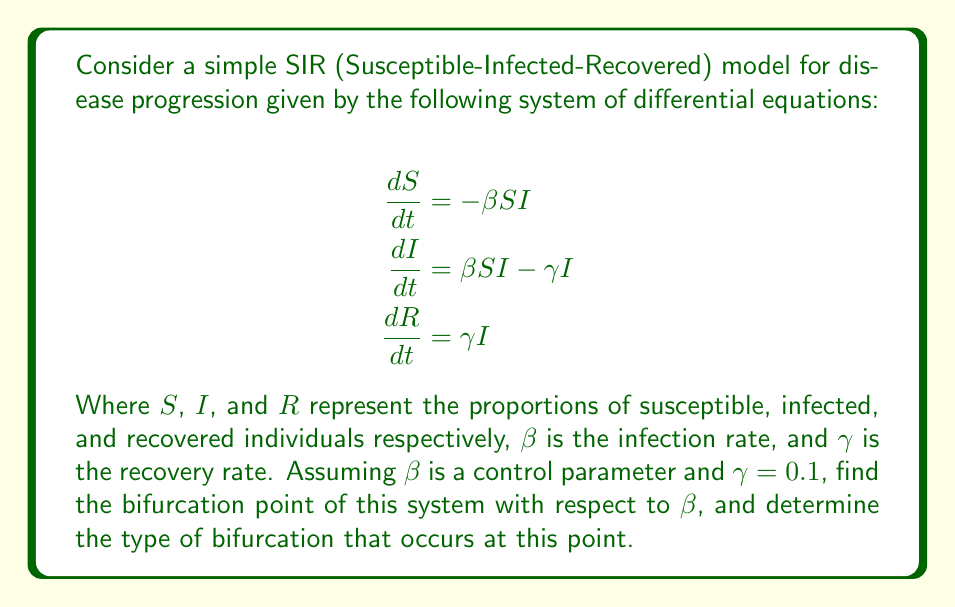Can you solve this math problem? To find the bifurcation point and determine the type of bifurcation, we'll follow these steps:

1) First, we need to find the equilibrium points of the system. At equilibrium, all derivatives are zero:

   $$\begin{align}
   -\beta SI &= 0 \\
   \beta SI - \gamma I &= 0 \\
   \gamma I &= 0
   \end{align}$$

2) From the third equation, we see that either $I = 0$ or $\gamma = 0$. Since $\gamma \neq 0$, we must have $I = 0$ at equilibrium.

3) This gives us two possible equilibrium points:
   - Disease-free equilibrium (DFE): $(S, I, R) = (1, 0, 0)$
   - Endemic equilibrium (EE): $(S, I, R) = (\frac{\gamma}{\beta}, \frac{\beta - \gamma}{\beta}, 1 - \frac{\gamma}{\beta})$

4) The endemic equilibrium only exists when $\beta > \gamma$, as $I$ must be non-negative.

5) To analyze stability, we need to compute the Jacobian matrix:

   $$J = \begin{bmatrix}
   -\beta I & -\beta S & 0 \\
   \beta I & \beta S - \gamma & 0 \\
   0 & \gamma & 0
   \end{bmatrix}$$

6) At the DFE, the Jacobian becomes:

   $$J_{DFE} = \begin{bmatrix}
   0 & -\beta & 0 \\
   0 & \beta - \gamma & 0 \\
   0 & \gamma & 0
   \end{bmatrix}$$

7) The eigenvalues of $J_{DFE}$ are $\lambda_1 = 0$, $\lambda_2 = \beta - \gamma$, and $\lambda_3 = 0$.

8) The stability of the DFE changes when $\lambda_2 = 0$, i.e., when $\beta = \gamma = 0.1$.

9) This point $\beta = 0.1$ is the bifurcation point. At this point, the DFE changes stability, and the endemic equilibrium emerges.

10) The type of bifurcation is a transcritical bifurcation, as the two equilibrium points (DFE and EE) exchange stability at the bifurcation point.
Answer: Bifurcation point: $\beta = 0.1$; Type: Transcritical bifurcation 